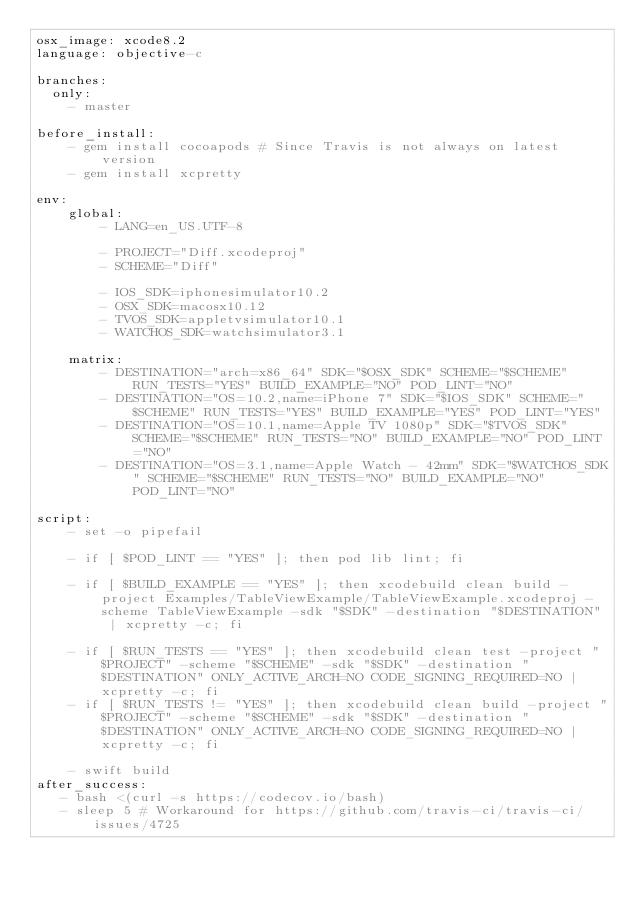Convert code to text. <code><loc_0><loc_0><loc_500><loc_500><_YAML_>osx_image: xcode8.2
language: objective-c

branches:
  only: 
    - master

before_install:
    - gem install cocoapods # Since Travis is not always on latest version
    - gem install xcpretty

env:
    global:
        - LANG=en_US.UTF-8

        - PROJECT="Diff.xcodeproj"
        - SCHEME="Diff"

        - IOS_SDK=iphonesimulator10.2
        - OSX_SDK=macosx10.12
        - TVOS_SDK=appletvsimulator10.1
        - WATCHOS_SDK=watchsimulator3.1

    matrix:
        - DESTINATION="arch=x86_64" SDK="$OSX_SDK" SCHEME="$SCHEME" RUN_TESTS="YES" BUILD_EXAMPLE="NO" POD_LINT="NO"
        - DESTINATION="OS=10.2,name=iPhone 7" SDK="$IOS_SDK" SCHEME="$SCHEME" RUN_TESTS="YES" BUILD_EXAMPLE="YES" POD_LINT="YES"
        - DESTINATION="OS=10.1,name=Apple TV 1080p" SDK="$TVOS_SDK" SCHEME="$SCHEME" RUN_TESTS="NO" BUILD_EXAMPLE="NO" POD_LINT="NO"
        - DESTINATION="OS=3.1,name=Apple Watch - 42mm" SDK="$WATCHOS_SDK" SCHEME="$SCHEME" RUN_TESTS="NO" BUILD_EXAMPLE="NO" POD_LINT="NO"

script:
    - set -o pipefail

    - if [ $POD_LINT == "YES" ]; then pod lib lint; fi

    - if [ $BUILD_EXAMPLE == "YES" ]; then xcodebuild clean build -project Examples/TableViewExample/TableViewExample.xcodeproj -scheme TableViewExample -sdk "$SDK" -destination "$DESTINATION" | xcpretty -c; fi

    - if [ $RUN_TESTS == "YES" ]; then xcodebuild clean test -project "$PROJECT" -scheme "$SCHEME" -sdk "$SDK" -destination "$DESTINATION" ONLY_ACTIVE_ARCH=NO CODE_SIGNING_REQUIRED=NO | xcpretty -c; fi
    - if [ $RUN_TESTS != "YES" ]; then xcodebuild clean build -project "$PROJECT" -scheme "$SCHEME" -sdk "$SDK" -destination "$DESTINATION" ONLY_ACTIVE_ARCH=NO CODE_SIGNING_REQUIRED=NO | xcpretty -c; fi

    - swift build
after_success:
   - bash <(curl -s https://codecov.io/bash)
   - sleep 5 # Workaround for https://github.com/travis-ci/travis-ci/issues/4725
</code> 